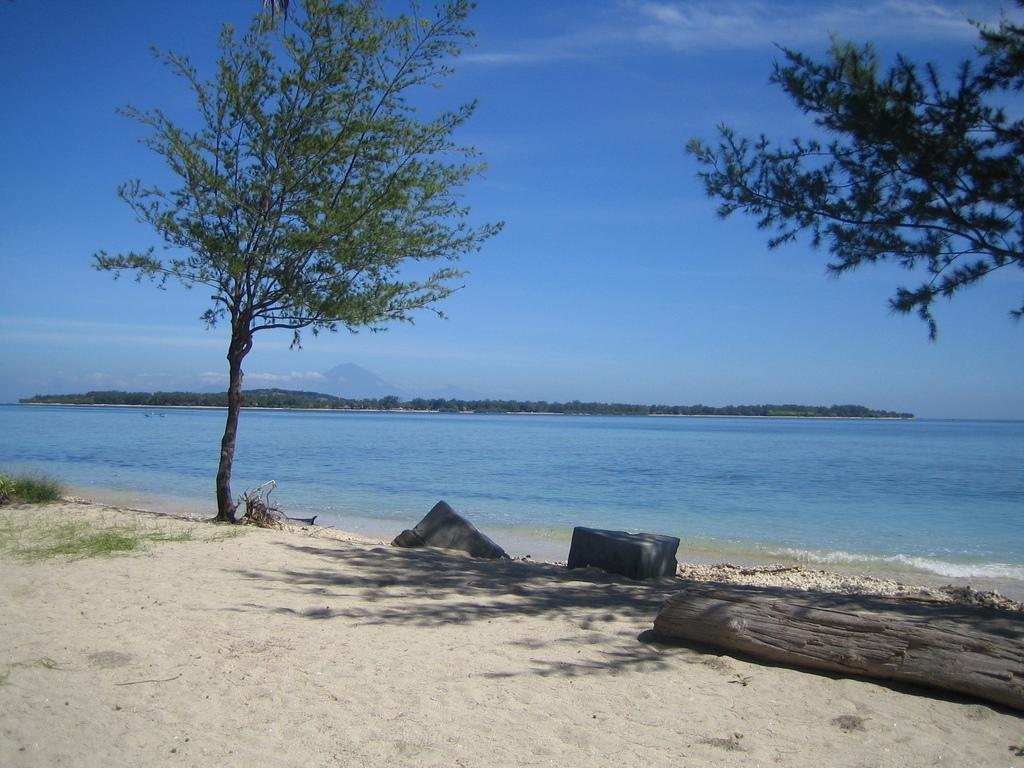What type of terrain is visible in the image? There is sand, a tree trunk, trees, grass, water, and hills visible in the image. Can you describe the vegetation in the image? There is a tree trunk and trees visible in the image. What type of natural environment is depicted in the image? The image features a combination of sand, grass, water, and hills, suggesting a diverse landscape. What is the color of the sky in the background? The sky is blue in the background. Are there any clouds visible in the sky? Yes, there are clouds in the sky. How many women are using hammers to alleviate their pain in the image? There are no women or hammers present in the image. 